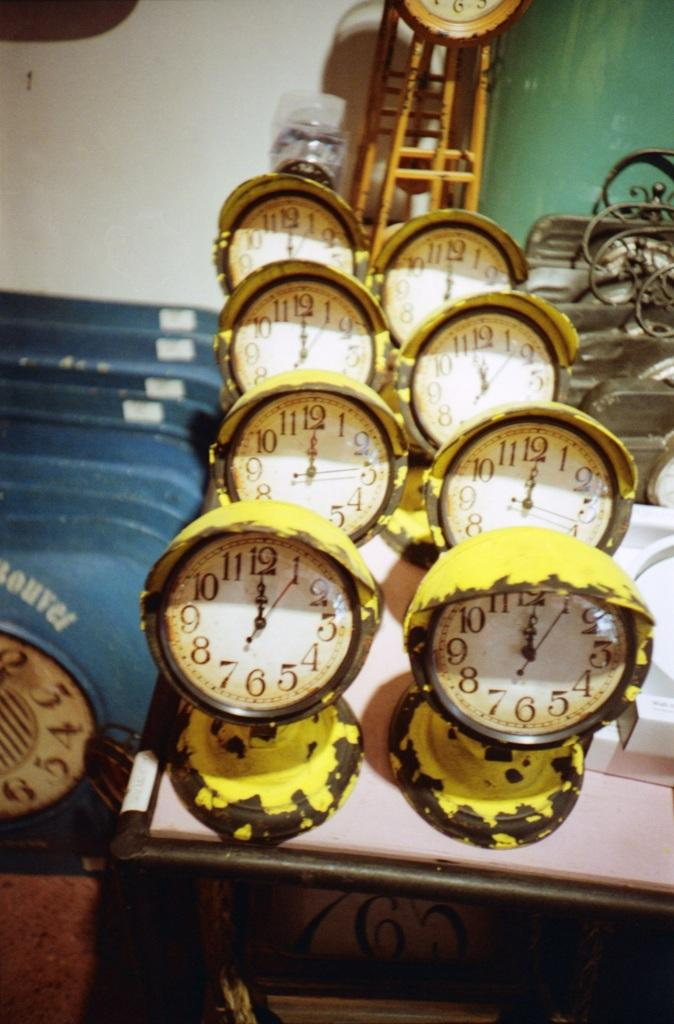<image>
Render a clear and concise summary of the photo. A row of painted yellow clocks all say 12 of clock. 